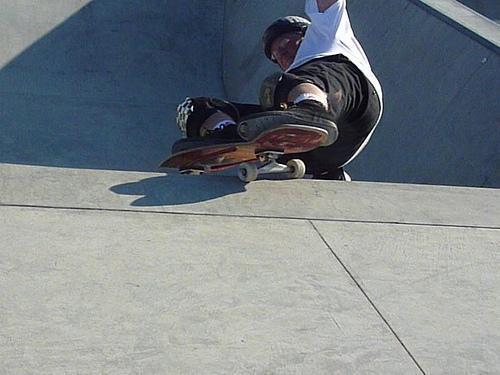How many people are in the picture?
Give a very brief answer. 1. 